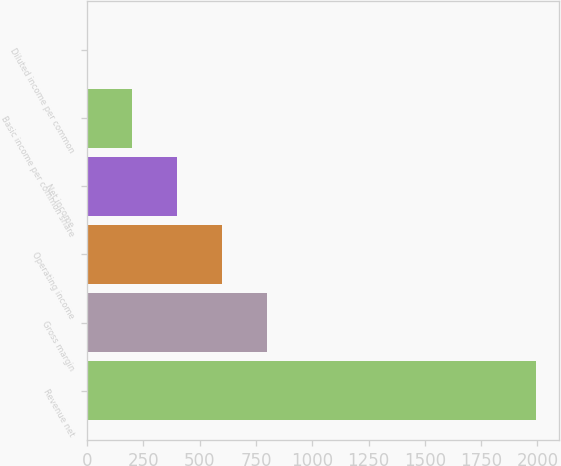<chart> <loc_0><loc_0><loc_500><loc_500><bar_chart><fcel>Revenue net<fcel>Gross margin<fcel>Operating income<fcel>Net income<fcel>Basic income per common share<fcel>Diluted income per common<nl><fcel>1995<fcel>798.37<fcel>598.93<fcel>399.49<fcel>200.05<fcel>0.61<nl></chart> 